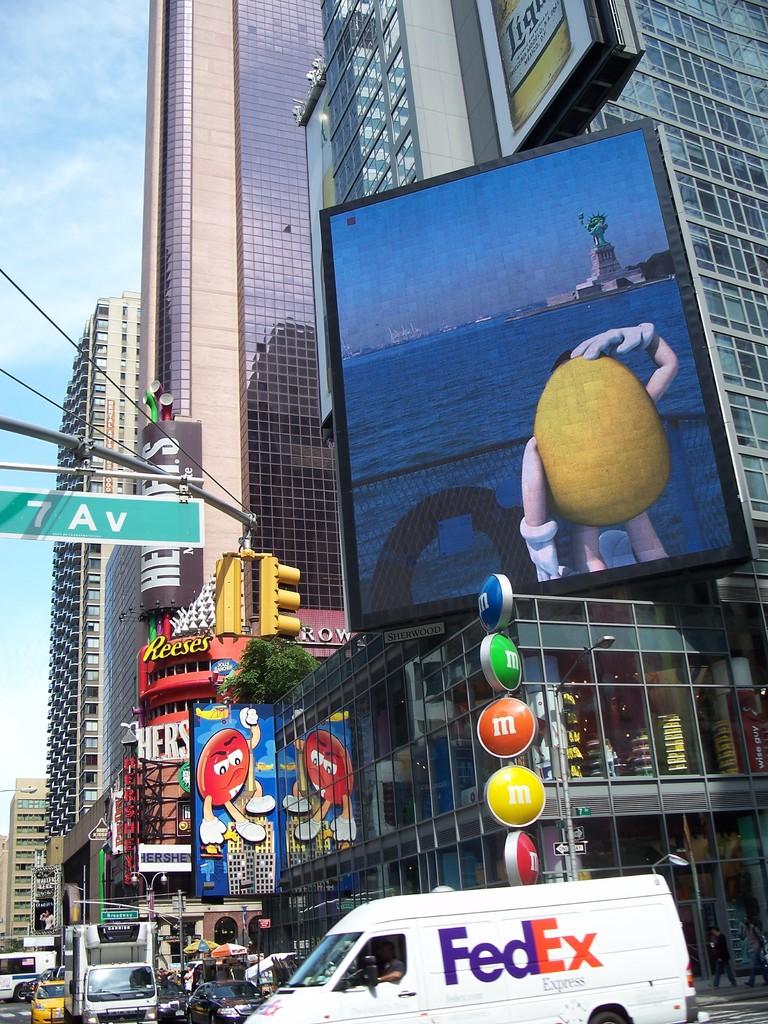What courier company is the white truck part of?
Offer a terse response. Fedex. Is this 7th avenue?
Keep it short and to the point. Yes. 